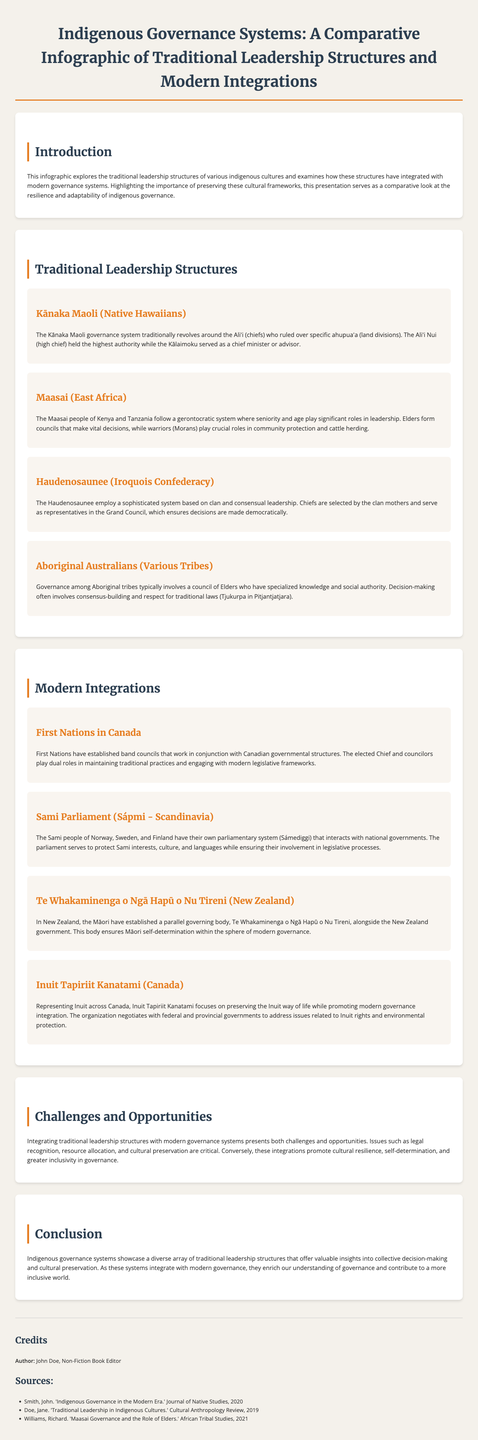What does the Kānaka Maoli governance system revolve around? The Kānaka Maoli governance system revolves around the Aliʻi (chiefs) who ruled over specific ahupuaʻa (land divisions).
Answer: Aliʻi What is the highest authority among Kānaka Maoli? The highest authority among Kānaka Maoli is the Aliʻi Nui (high chief).
Answer: Aliʻi Nui Which governance system involves councils formed by elders? The Maasai people of Kenya and Tanzania follow a gerontocratic system where seniority and age play significant roles in leadership.
Answer: Gerontocratic What do Aboriginal tribes typically involve in their governance? Governance among Aboriginal tribes typically involves a council of Elders who have specialized knowledge and social authority.
Answer: Council of Elders What do First Nations in Canada maintain alongside their modern governance? First Nations maintain traditional practices alongside their modern governance structures.
Answer: Traditional practices What is the name of the Sami parliamentary system? The Sami parliamentary system is called Sámediggi.
Answer: Sámediggi What is the role of the Inuit Tapiriit Kanatami? Inuit Tapiriit Kanatami focuses on preserving the Inuit way of life while promoting modern governance integration.
Answer: Preserving the Inuit way of life What challenges does integrating traditional leadership structures with modern governance present? Integrating traditional leadership structures with modern governance presents challenges such as legal recognition, resource allocation, and cultural preservation.
Answer: Legal recognition What does the Haudenosaunee employ in their governance system? The Haudenosaunee employ a sophisticated system based on clan and consensual leadership.
Answer: Clan and consensual leadership What does the infographic highlight regarding indigenous governance structures? The infographic highlights the importance of preserving these cultural frameworks.
Answer: Importance of preserving cultural frameworks 